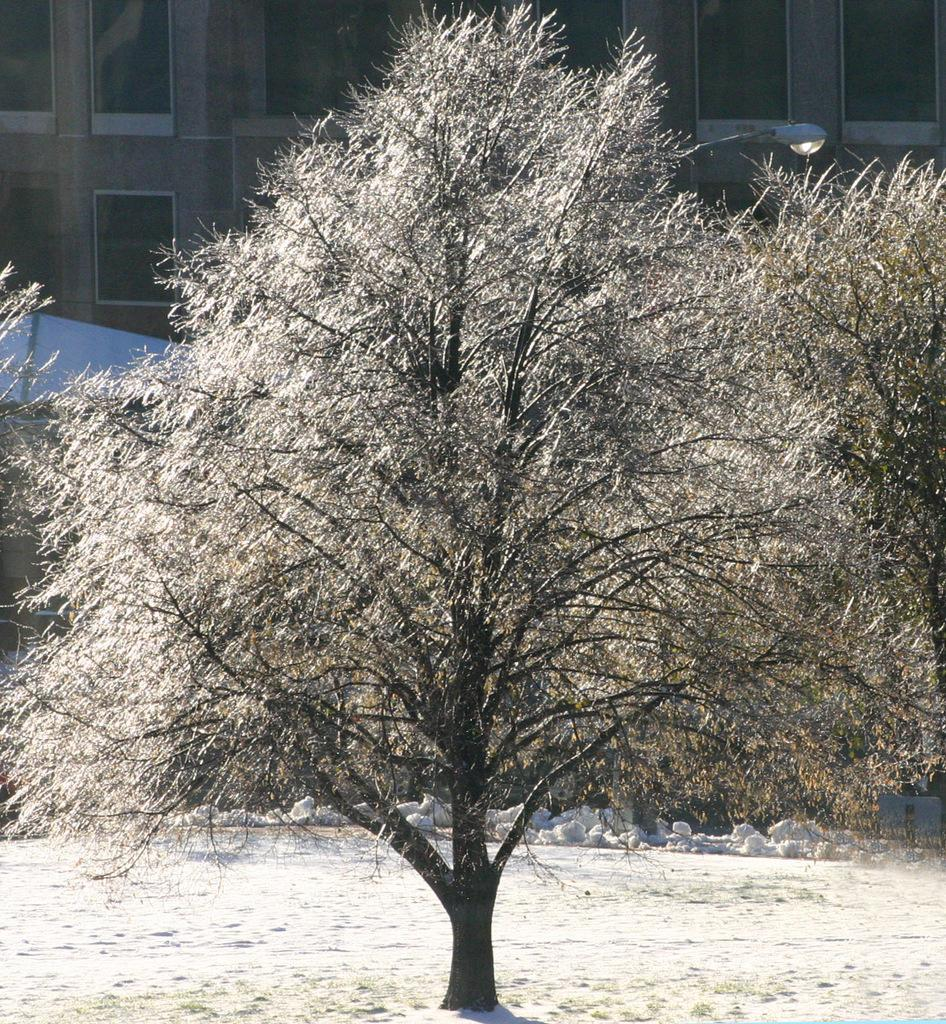What type of natural elements can be seen in the image? There are trees in the image. What type of artificial element can be seen in the image? There is a building in the image. What type of man-made object can be seen in the image? There is a light in the image. What type of architectural feature can be seen in the image? There are windows in the image. Can you tell me how many shoes are visible in the image? There are no shoes present in the image. Is there any quicksand visible in the image? There is no quicksand present in the image. 